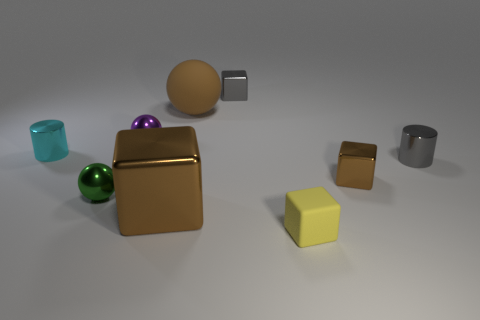Subtract 1 blocks. How many blocks are left? 3 Add 1 small rubber blocks. How many objects exist? 10 Subtract all spheres. How many objects are left? 6 Add 2 green objects. How many green objects exist? 3 Subtract 1 gray cylinders. How many objects are left? 8 Subtract all large objects. Subtract all small cylinders. How many objects are left? 5 Add 1 tiny purple metal spheres. How many tiny purple metal spheres are left? 2 